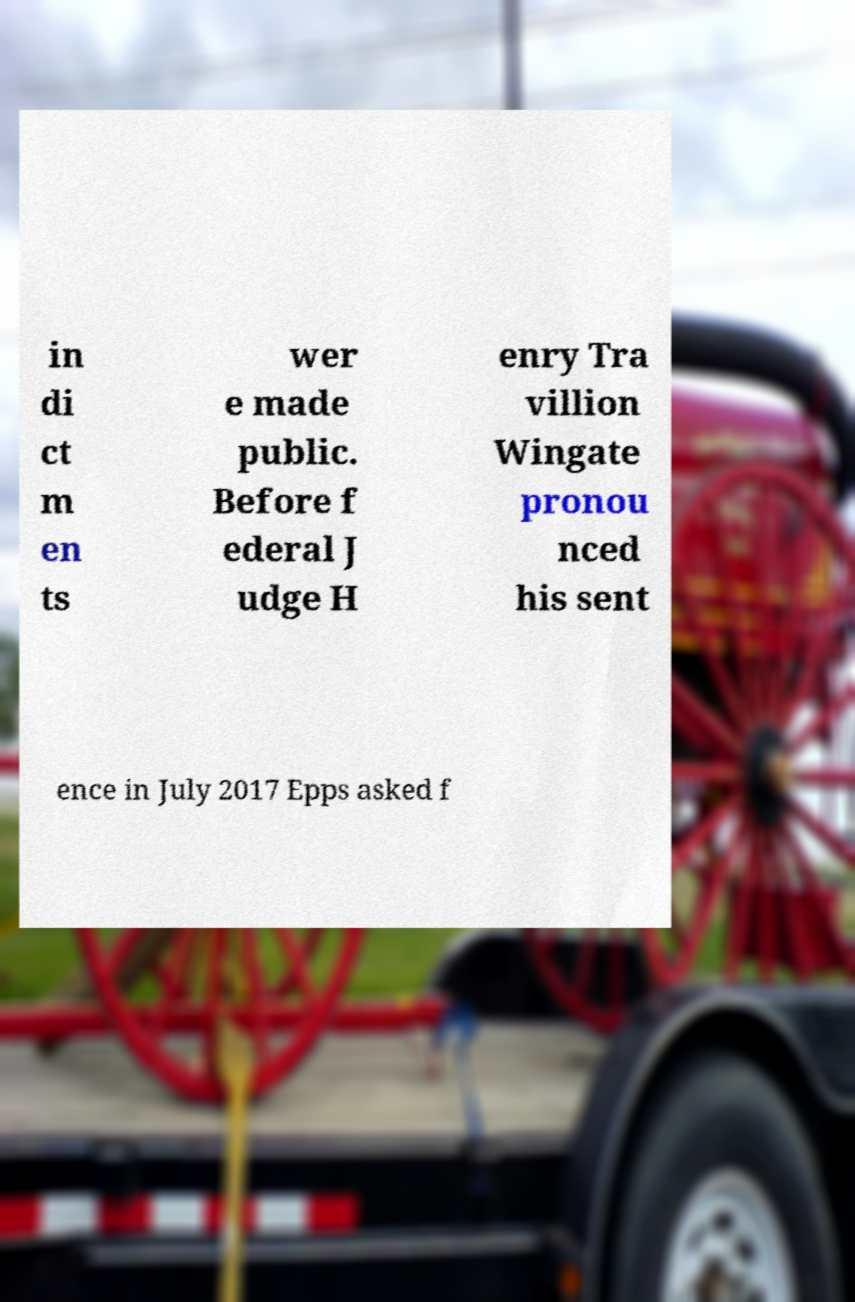Could you assist in decoding the text presented in this image and type it out clearly? in di ct m en ts wer e made public. Before f ederal J udge H enry Tra villion Wingate pronou nced his sent ence in July 2017 Epps asked f 